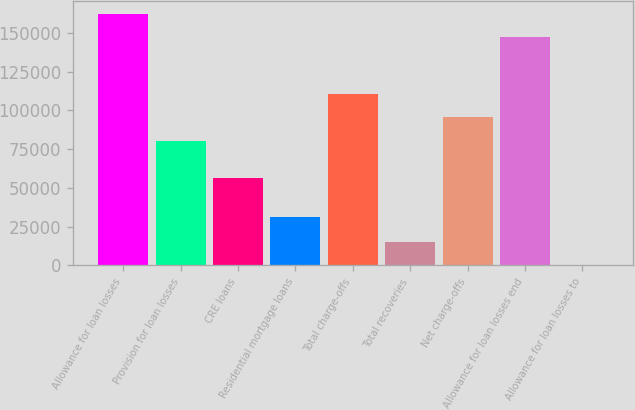Convert chart. <chart><loc_0><loc_0><loc_500><loc_500><bar_chart><fcel>Allowance for loan losses<fcel>Provision for loan losses<fcel>CRE loans<fcel>Residential mortgage loans<fcel>Total charge-offs<fcel>Total recoveries<fcel>Net charge-offs<fcel>Allowance for loan losses end<fcel>Allowance for loan losses to<nl><fcel>162111<fcel>80413<fcel>56402<fcel>30837<fcel>110467<fcel>15029.3<fcel>95440<fcel>147084<fcel>2.36<nl></chart> 